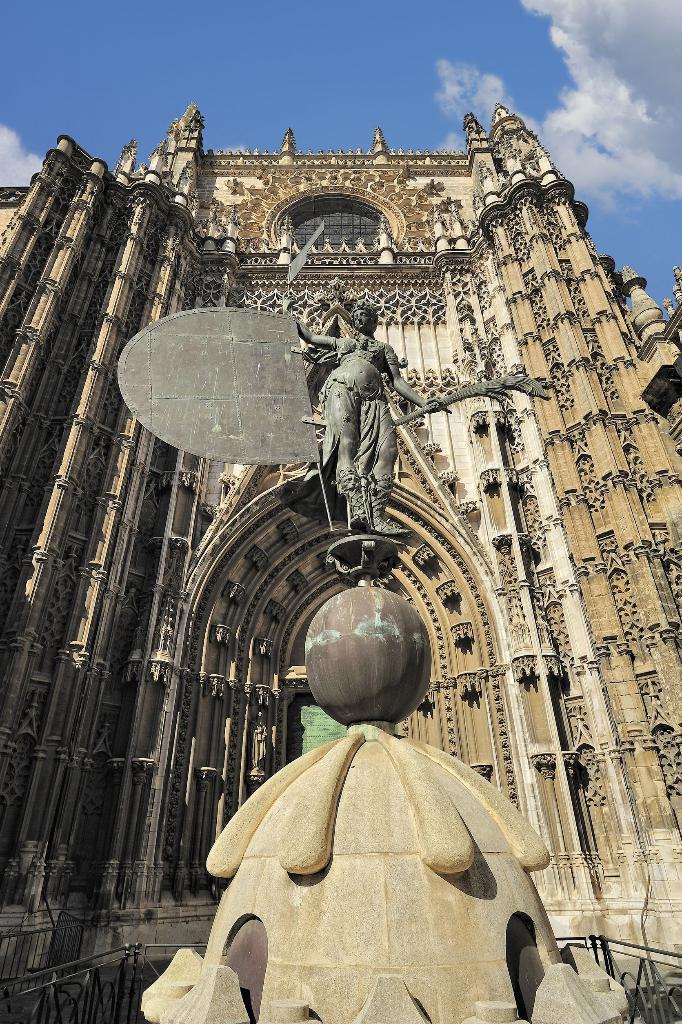How would you summarize this image in a sentence or two? In the picture we can see a historical construction and a sculpture on the wall and near to it, we can see a sculpture standing on the round stone in the path, in the background we can see a sky and clouds. 